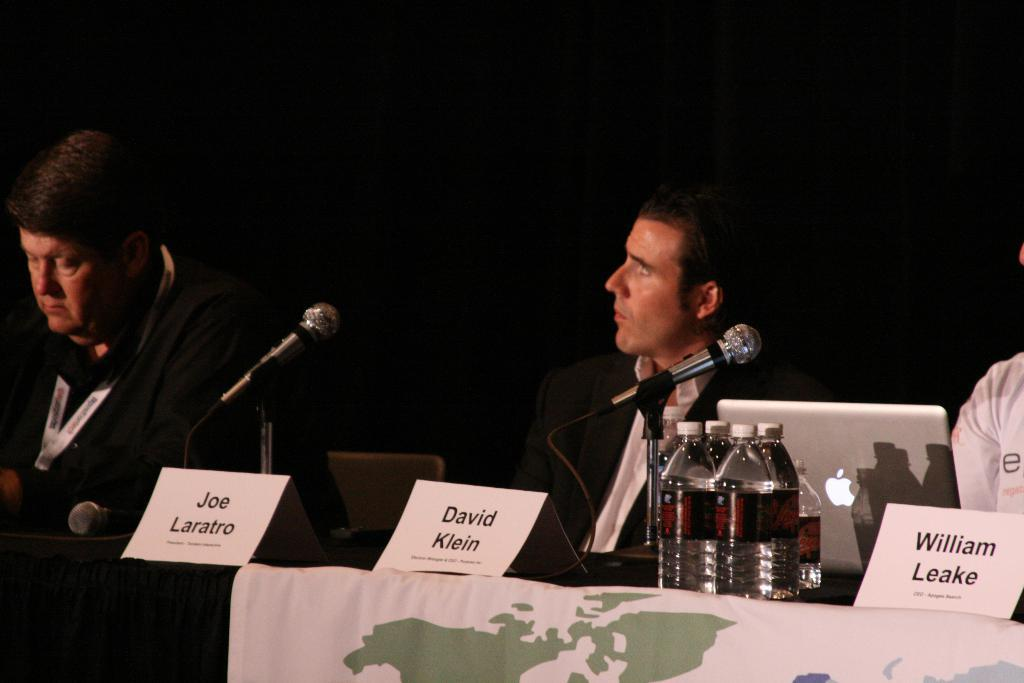How many people are present in the image? There are three persons in the image. What are the people doing in the image? The three persons are sitting in front of a table. What objects can be seen on the table? There are three name boards, a few bottles, a laptop, and two microphones on the table. What type of skin condition is visible on the person sitting on the left side of the table? There is no information about any skin conditions visible on the people in the image. 